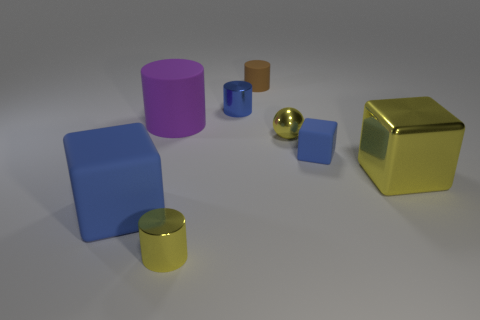Are the big yellow object and the large cylinder made of the same material?
Make the answer very short. No. How many balls are either big blue rubber objects or small blue things?
Keep it short and to the point. 0. There is a cylinder in front of the large blue object; what color is it?
Give a very brief answer. Yellow. What number of metal things are small purple cubes or tiny yellow things?
Offer a terse response. 2. What is the material of the thing that is behind the blue object that is behind the small block?
Keep it short and to the point. Rubber. There is a small thing that is the same color as the tiny sphere; what material is it?
Your answer should be very brief. Metal. What color is the tiny sphere?
Your answer should be very brief. Yellow. Is there a yellow ball that is in front of the matte cube right of the small brown cylinder?
Your response must be concise. No. What is the tiny blue cylinder made of?
Give a very brief answer. Metal. Is the blue cube that is left of the brown rubber object made of the same material as the tiny yellow thing that is to the right of the tiny brown rubber cylinder?
Make the answer very short. No. 